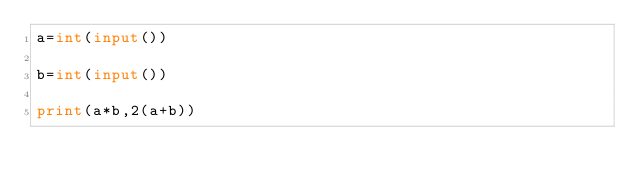<code> <loc_0><loc_0><loc_500><loc_500><_Python_>a=int(input())

b=int(input())

print(a*b,2(a+b))
</code> 